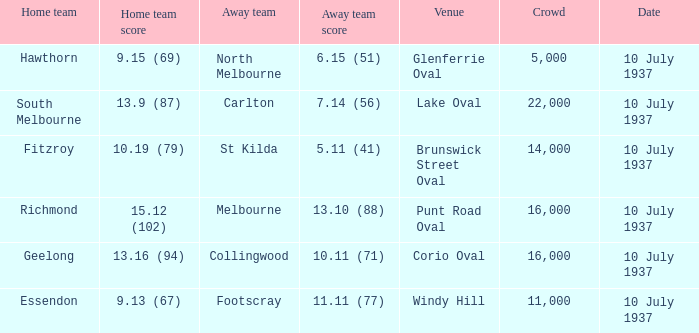What is the lowest Crowd with a Home Team Score of 9.15 (69)? 5000.0. 